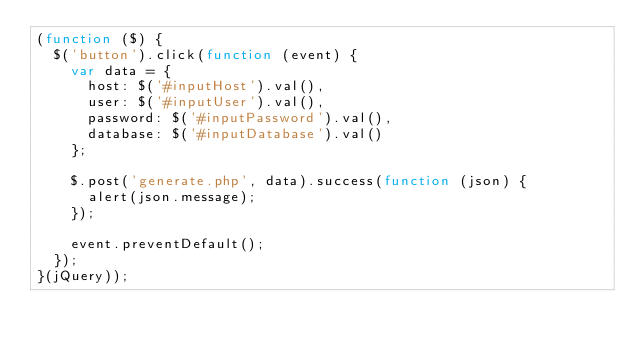Convert code to text. <code><loc_0><loc_0><loc_500><loc_500><_JavaScript_>(function ($) {
	$('button').click(function (event) {
		var data = {
			host: $('#inputHost').val(),
			user: $('#inputUser').val(),
			password: $('#inputPassword').val(),
			database: $('#inputDatabase').val()
		};

		$.post('generate.php', data).success(function (json) {
			alert(json.message);
		});

		event.preventDefault();
	});
}(jQuery));</code> 